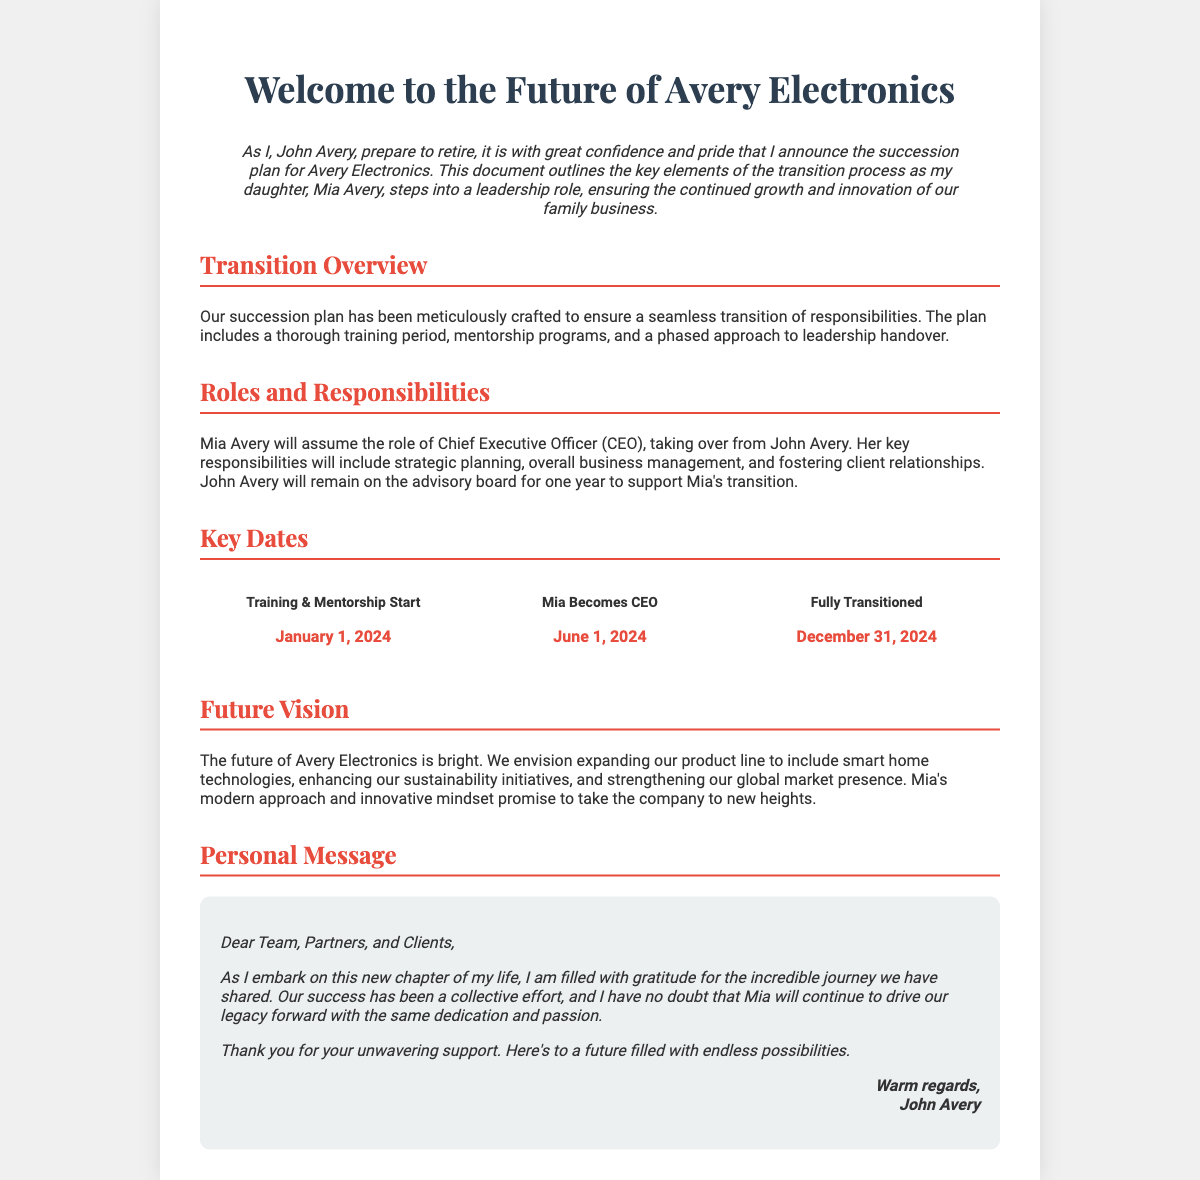what is the name of the business? The business being discussed in the document is named Avery Electronics.
Answer: Avery Electronics who is transitioning into the CEO role? The individual transitioning into the CEO role is named Mia Avery, who is the daughter of John Avery.
Answer: Mia Avery what is the start date for training and mentorship? The document specifies that the training and mentorship will begin on January 1, 2024.
Answer: January 1, 2024 when does Mia become CEO? According to the document, Mia will officially become the CEO on June 1, 2024.
Answer: June 1, 2024 what is John Avery's role after the transition? After the transition, John Avery will remain on the advisory board for one year.
Answer: advisory board what vision is outlined for the future of the business? The future vision includes expanding the product line to include smart home technologies and enhancing sustainability initiatives.
Answer: expanding product line how long will the transition period last? The transition period is set to last until December 31, 2024.
Answer: December 31, 2024 what personal message does John Avery convey? John Avery conveys gratitude and confidence in Mia's capability to drive the business forward.
Answer: gratitude and confidence what color is the section header for "Roles and Responsibilities"? The section header for "Roles and Responsibilities" is colored red, identified by the hex code #e74c3c.
Answer: red 